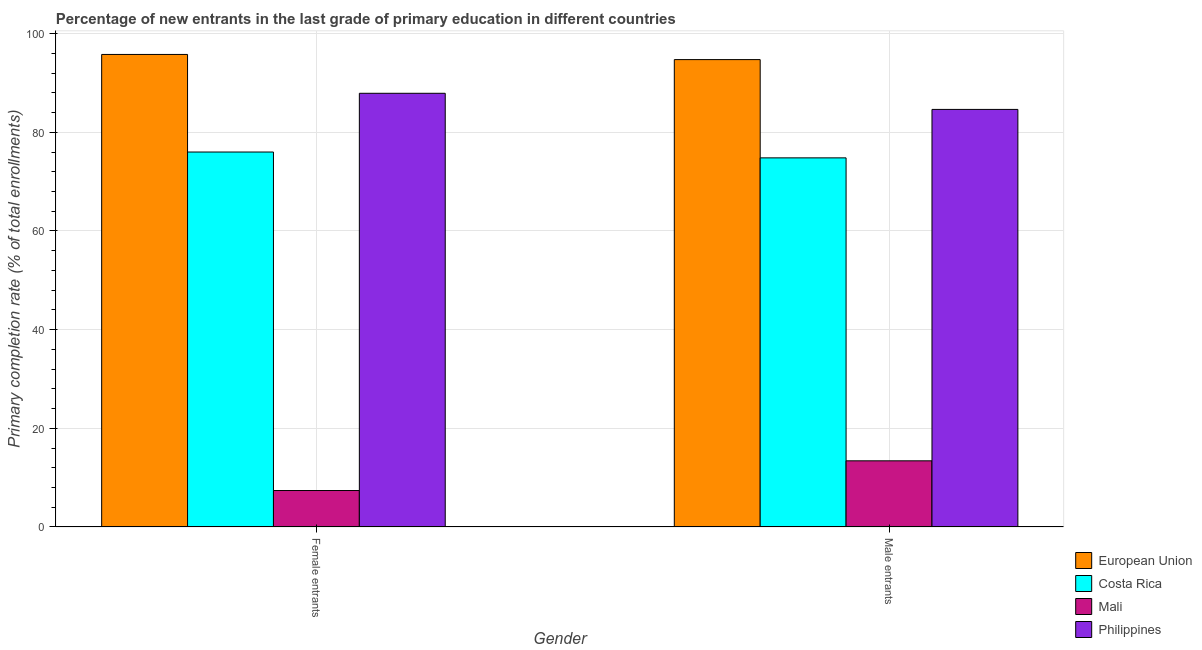How many different coloured bars are there?
Your answer should be very brief. 4. Are the number of bars on each tick of the X-axis equal?
Offer a very short reply. Yes. How many bars are there on the 2nd tick from the left?
Ensure brevity in your answer.  4. What is the label of the 1st group of bars from the left?
Your response must be concise. Female entrants. What is the primary completion rate of female entrants in Costa Rica?
Provide a succinct answer. 76. Across all countries, what is the maximum primary completion rate of male entrants?
Offer a terse response. 94.73. Across all countries, what is the minimum primary completion rate of female entrants?
Keep it short and to the point. 7.39. In which country was the primary completion rate of male entrants minimum?
Give a very brief answer. Mali. What is the total primary completion rate of male entrants in the graph?
Make the answer very short. 267.6. What is the difference between the primary completion rate of male entrants in Philippines and that in Costa Rica?
Give a very brief answer. 9.82. What is the difference between the primary completion rate of female entrants in Costa Rica and the primary completion rate of male entrants in European Union?
Your answer should be very brief. -18.73. What is the average primary completion rate of male entrants per country?
Offer a very short reply. 66.9. What is the difference between the primary completion rate of male entrants and primary completion rate of female entrants in Costa Rica?
Give a very brief answer. -1.18. What is the ratio of the primary completion rate of male entrants in Mali to that in European Union?
Your answer should be very brief. 0.14. What does the 1st bar from the left in Male entrants represents?
Offer a very short reply. European Union. What does the 2nd bar from the right in Female entrants represents?
Provide a succinct answer. Mali. How many bars are there?
Offer a very short reply. 8. Are all the bars in the graph horizontal?
Offer a very short reply. No. Are the values on the major ticks of Y-axis written in scientific E-notation?
Offer a terse response. No. Where does the legend appear in the graph?
Ensure brevity in your answer.  Bottom right. How many legend labels are there?
Provide a short and direct response. 4. What is the title of the graph?
Offer a very short reply. Percentage of new entrants in the last grade of primary education in different countries. Does "Saudi Arabia" appear as one of the legend labels in the graph?
Provide a short and direct response. No. What is the label or title of the Y-axis?
Offer a terse response. Primary completion rate (% of total enrollments). What is the Primary completion rate (% of total enrollments) in European Union in Female entrants?
Ensure brevity in your answer.  95.78. What is the Primary completion rate (% of total enrollments) in Costa Rica in Female entrants?
Make the answer very short. 76. What is the Primary completion rate (% of total enrollments) in Mali in Female entrants?
Offer a terse response. 7.39. What is the Primary completion rate (% of total enrollments) in Philippines in Female entrants?
Ensure brevity in your answer.  87.91. What is the Primary completion rate (% of total enrollments) of European Union in Male entrants?
Ensure brevity in your answer.  94.73. What is the Primary completion rate (% of total enrollments) of Costa Rica in Male entrants?
Ensure brevity in your answer.  74.82. What is the Primary completion rate (% of total enrollments) of Mali in Male entrants?
Your response must be concise. 13.41. What is the Primary completion rate (% of total enrollments) in Philippines in Male entrants?
Ensure brevity in your answer.  84.64. Across all Gender, what is the maximum Primary completion rate (% of total enrollments) in European Union?
Ensure brevity in your answer.  95.78. Across all Gender, what is the maximum Primary completion rate (% of total enrollments) in Costa Rica?
Your response must be concise. 76. Across all Gender, what is the maximum Primary completion rate (% of total enrollments) in Mali?
Keep it short and to the point. 13.41. Across all Gender, what is the maximum Primary completion rate (% of total enrollments) of Philippines?
Ensure brevity in your answer.  87.91. Across all Gender, what is the minimum Primary completion rate (% of total enrollments) of European Union?
Offer a terse response. 94.73. Across all Gender, what is the minimum Primary completion rate (% of total enrollments) of Costa Rica?
Your answer should be compact. 74.82. Across all Gender, what is the minimum Primary completion rate (% of total enrollments) in Mali?
Provide a succinct answer. 7.39. Across all Gender, what is the minimum Primary completion rate (% of total enrollments) in Philippines?
Keep it short and to the point. 84.64. What is the total Primary completion rate (% of total enrollments) in European Union in the graph?
Keep it short and to the point. 190.51. What is the total Primary completion rate (% of total enrollments) of Costa Rica in the graph?
Your answer should be compact. 150.82. What is the total Primary completion rate (% of total enrollments) in Mali in the graph?
Offer a terse response. 20.8. What is the total Primary completion rate (% of total enrollments) in Philippines in the graph?
Your response must be concise. 172.54. What is the difference between the Primary completion rate (% of total enrollments) of European Union in Female entrants and that in Male entrants?
Keep it short and to the point. 1.04. What is the difference between the Primary completion rate (% of total enrollments) of Costa Rica in Female entrants and that in Male entrants?
Keep it short and to the point. 1.18. What is the difference between the Primary completion rate (% of total enrollments) in Mali in Female entrants and that in Male entrants?
Provide a succinct answer. -6.02. What is the difference between the Primary completion rate (% of total enrollments) of Philippines in Female entrants and that in Male entrants?
Your answer should be compact. 3.27. What is the difference between the Primary completion rate (% of total enrollments) in European Union in Female entrants and the Primary completion rate (% of total enrollments) in Costa Rica in Male entrants?
Offer a terse response. 20.96. What is the difference between the Primary completion rate (% of total enrollments) of European Union in Female entrants and the Primary completion rate (% of total enrollments) of Mali in Male entrants?
Give a very brief answer. 82.36. What is the difference between the Primary completion rate (% of total enrollments) in European Union in Female entrants and the Primary completion rate (% of total enrollments) in Philippines in Male entrants?
Ensure brevity in your answer.  11.14. What is the difference between the Primary completion rate (% of total enrollments) of Costa Rica in Female entrants and the Primary completion rate (% of total enrollments) of Mali in Male entrants?
Give a very brief answer. 62.59. What is the difference between the Primary completion rate (% of total enrollments) in Costa Rica in Female entrants and the Primary completion rate (% of total enrollments) in Philippines in Male entrants?
Offer a terse response. -8.64. What is the difference between the Primary completion rate (% of total enrollments) in Mali in Female entrants and the Primary completion rate (% of total enrollments) in Philippines in Male entrants?
Provide a succinct answer. -77.25. What is the average Primary completion rate (% of total enrollments) of European Union per Gender?
Make the answer very short. 95.25. What is the average Primary completion rate (% of total enrollments) in Costa Rica per Gender?
Your response must be concise. 75.41. What is the average Primary completion rate (% of total enrollments) in Mali per Gender?
Provide a short and direct response. 10.4. What is the average Primary completion rate (% of total enrollments) of Philippines per Gender?
Provide a short and direct response. 86.27. What is the difference between the Primary completion rate (% of total enrollments) of European Union and Primary completion rate (% of total enrollments) of Costa Rica in Female entrants?
Give a very brief answer. 19.78. What is the difference between the Primary completion rate (% of total enrollments) in European Union and Primary completion rate (% of total enrollments) in Mali in Female entrants?
Your answer should be compact. 88.38. What is the difference between the Primary completion rate (% of total enrollments) in European Union and Primary completion rate (% of total enrollments) in Philippines in Female entrants?
Offer a very short reply. 7.87. What is the difference between the Primary completion rate (% of total enrollments) of Costa Rica and Primary completion rate (% of total enrollments) of Mali in Female entrants?
Your response must be concise. 68.61. What is the difference between the Primary completion rate (% of total enrollments) in Costa Rica and Primary completion rate (% of total enrollments) in Philippines in Female entrants?
Your response must be concise. -11.91. What is the difference between the Primary completion rate (% of total enrollments) of Mali and Primary completion rate (% of total enrollments) of Philippines in Female entrants?
Provide a succinct answer. -80.51. What is the difference between the Primary completion rate (% of total enrollments) of European Union and Primary completion rate (% of total enrollments) of Costa Rica in Male entrants?
Provide a short and direct response. 19.92. What is the difference between the Primary completion rate (% of total enrollments) in European Union and Primary completion rate (% of total enrollments) in Mali in Male entrants?
Give a very brief answer. 81.32. What is the difference between the Primary completion rate (% of total enrollments) of European Union and Primary completion rate (% of total enrollments) of Philippines in Male entrants?
Provide a short and direct response. 10.1. What is the difference between the Primary completion rate (% of total enrollments) of Costa Rica and Primary completion rate (% of total enrollments) of Mali in Male entrants?
Offer a terse response. 61.4. What is the difference between the Primary completion rate (% of total enrollments) in Costa Rica and Primary completion rate (% of total enrollments) in Philippines in Male entrants?
Provide a short and direct response. -9.82. What is the difference between the Primary completion rate (% of total enrollments) in Mali and Primary completion rate (% of total enrollments) in Philippines in Male entrants?
Offer a terse response. -71.22. What is the ratio of the Primary completion rate (% of total enrollments) of European Union in Female entrants to that in Male entrants?
Make the answer very short. 1.01. What is the ratio of the Primary completion rate (% of total enrollments) in Costa Rica in Female entrants to that in Male entrants?
Keep it short and to the point. 1.02. What is the ratio of the Primary completion rate (% of total enrollments) in Mali in Female entrants to that in Male entrants?
Your answer should be compact. 0.55. What is the ratio of the Primary completion rate (% of total enrollments) of Philippines in Female entrants to that in Male entrants?
Your answer should be compact. 1.04. What is the difference between the highest and the second highest Primary completion rate (% of total enrollments) in European Union?
Give a very brief answer. 1.04. What is the difference between the highest and the second highest Primary completion rate (% of total enrollments) in Costa Rica?
Provide a short and direct response. 1.18. What is the difference between the highest and the second highest Primary completion rate (% of total enrollments) in Mali?
Keep it short and to the point. 6.02. What is the difference between the highest and the second highest Primary completion rate (% of total enrollments) in Philippines?
Your answer should be very brief. 3.27. What is the difference between the highest and the lowest Primary completion rate (% of total enrollments) of European Union?
Your answer should be compact. 1.04. What is the difference between the highest and the lowest Primary completion rate (% of total enrollments) in Costa Rica?
Ensure brevity in your answer.  1.18. What is the difference between the highest and the lowest Primary completion rate (% of total enrollments) in Mali?
Provide a short and direct response. 6.02. What is the difference between the highest and the lowest Primary completion rate (% of total enrollments) of Philippines?
Ensure brevity in your answer.  3.27. 